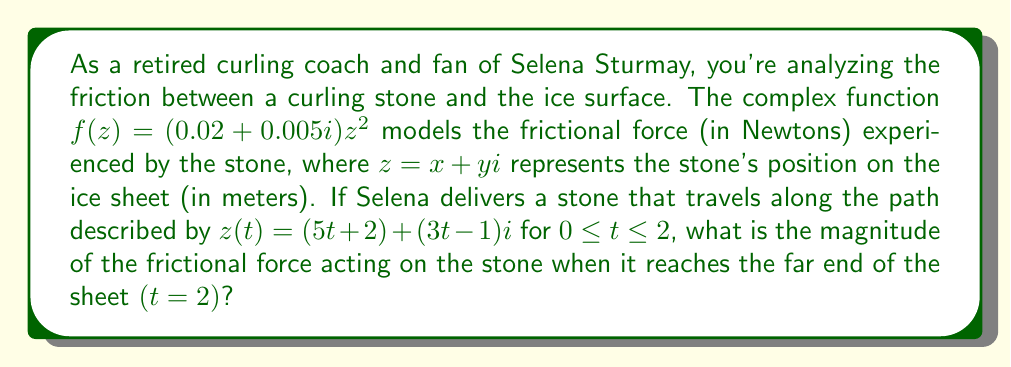Help me with this question. Let's approach this step-by-step:

1) First, we need to find the position of the stone at $t = 2$:
   $z(2) = (5(2) + 2) + (3(2) - 1)i = 12 + 5i$

2) Now, we substitute this value into our friction function:
   $f(z) = (0.02 + 0.005i)(12 + 5i)^2$

3) Let's expand $(12 + 5i)^2$:
   $(12 + 5i)^2 = 144 + 120i + 25i^2 = 144 + 120i - 25 = 119 + 120i$

4) Now our function becomes:
   $f(z) = (0.02 + 0.005i)(119 + 120i)$

5) Let's multiply these complex numbers:
   $f(z) = (0.02 \cdot 119 - 0.005 \cdot 120) + (0.02 \cdot 120 + 0.005 \cdot 119)i$
   $f(z) = 1.78 + 2.995i$

6) To find the magnitude of this force, we use the absolute value of a complex number:
   $|f(z)| = \sqrt{(1.78)^2 + (2.995)^2}$

7) Calculate:
   $|f(z)| = \sqrt{3.1684 + 8.9700} = \sqrt{12.1384} \approx 3.48$ N
Answer: The magnitude of the frictional force acting on the stone when it reaches the far end of the sheet is approximately 3.48 N. 